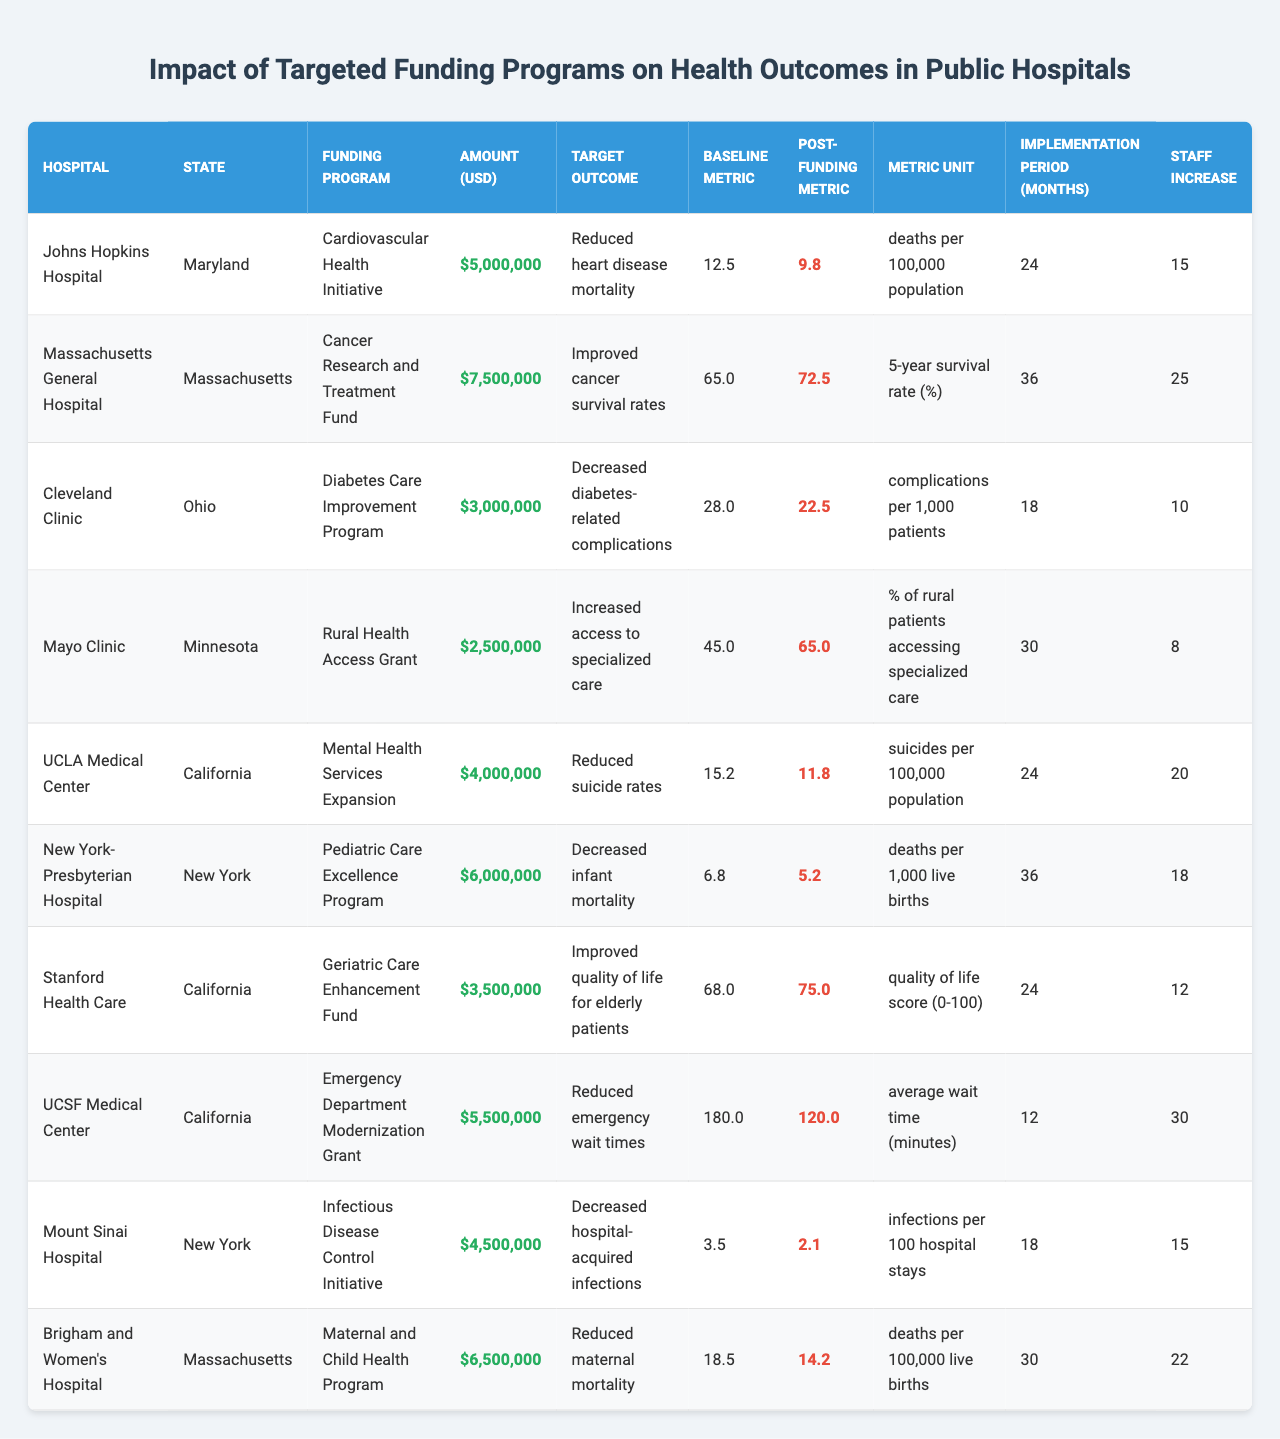What is the funding amount for Massachusetts General Hospital? According to the table, the funding amount for Massachusetts General Hospital is stated directly. It is $7,500,000.
Answer: $7,500,000 Which hospital received the lowest funding amount? By examining the funding amounts listed for each hospital, the lowest funding amount is $2,500,000, received by the Mayo Clinic.
Answer: Mayo Clinic How many months did it take for the funding implementation at Johns Hopkins Hospital? The implementation period for the funding program at Johns Hopkins Hospital is explicitly shown in the table as 24 months.
Answer: 24 months What target health outcome is associated with the Diabetes Care Improvement Program? The table lists the target health outcome for the Diabetes Care Improvement Program as "Decreased diabetes-related complications".
Answer: Decreased diabetes-related complications What is the difference between the baseline metric and the post-funding metric for the Geriatric Care Enhancement Fund? For the Geriatric Care Enhancement Fund, the baseline metric is 68.0, and the post-funding metric is 75.0. The difference is calculated as 75.0 - 68.0, which equals 7.0.
Answer: 7.0 Which hospital experienced a reduction in hospital-acquired infections after funding? The table indicates that Mount Sinai Hospital was focused on the Infectious Disease Control Initiative, which aims at reducing hospital-acquired infections, and the post-funding metric shows a decrease from 3.5 to 2.1.
Answer: Mount Sinai Hospital What is the average funding amount among all hospitals? To find the average, sum all funding amounts (5,000,000 + 7,500,000 + 3,000,000 + 2,500,000 + 4,000,000 + 6,000,000 + 3,500,000 + 5,500,000 + 4,500,000 + 6,500,000 = 44,000,000) and divide by the number of hospitals (10). Thus, the average funding amount is 44,000,000 / 10 = 4,400,000.
Answer: $4,400,000 Does the Pediatric Care Excellence Program have a higher post-funding metric than the baseline metric? The table shows that for the Pediatric Care Excellence Program, the baseline metric is 6.8 and the post-funding metric is 5.2, meaning the post-funding metric is lower. Therefore, the claim is false.
Answer: No Which state has the highest number of hospitals listed in the table? By counting the occurrences of each state in the table, California has the highest representation with three hospitals: UCLA Medical Center, Stanford Health Care, and UCSF Medical Center.
Answer: California What health outcome improvement was noted for the funding program associated with maternal health? The funding program related to maternal health is the Maternal and Child Health Program, which reported a reduction in maternal mortality. The baseline was 18.5, and the post-funding metric reduced it to 14.2, indicating an improvement.
Answer: Reduced maternal mortality Was there an increase in staff at the New York-Presbyterian Hospital after funding? The table indicates that the staff increase for New York-Presbyterian Hospital was 18. Thus, there was indeed an increase in staff after funding.
Answer: Yes 